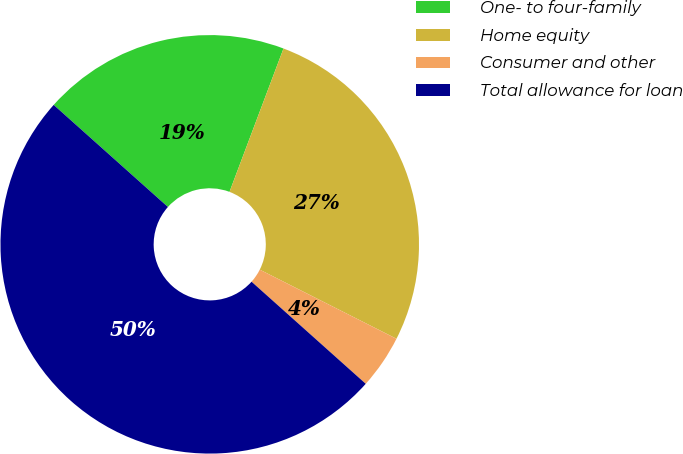Convert chart. <chart><loc_0><loc_0><loc_500><loc_500><pie_chart><fcel>One- to four-family<fcel>Home equity<fcel>Consumer and other<fcel>Total allowance for loan<nl><fcel>19.13%<fcel>26.72%<fcel>4.16%<fcel>50.0%<nl></chart> 